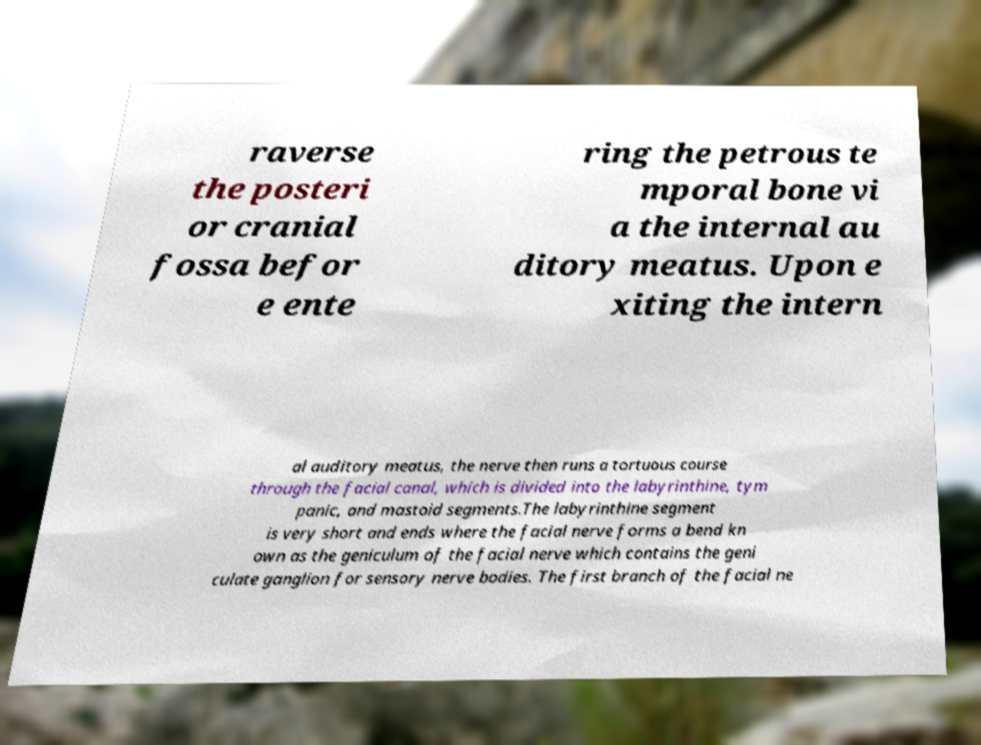Please read and relay the text visible in this image. What does it say? raverse the posteri or cranial fossa befor e ente ring the petrous te mporal bone vi a the internal au ditory meatus. Upon e xiting the intern al auditory meatus, the nerve then runs a tortuous course through the facial canal, which is divided into the labyrinthine, tym panic, and mastoid segments.The labyrinthine segment is very short and ends where the facial nerve forms a bend kn own as the geniculum of the facial nerve which contains the geni culate ganglion for sensory nerve bodies. The first branch of the facial ne 